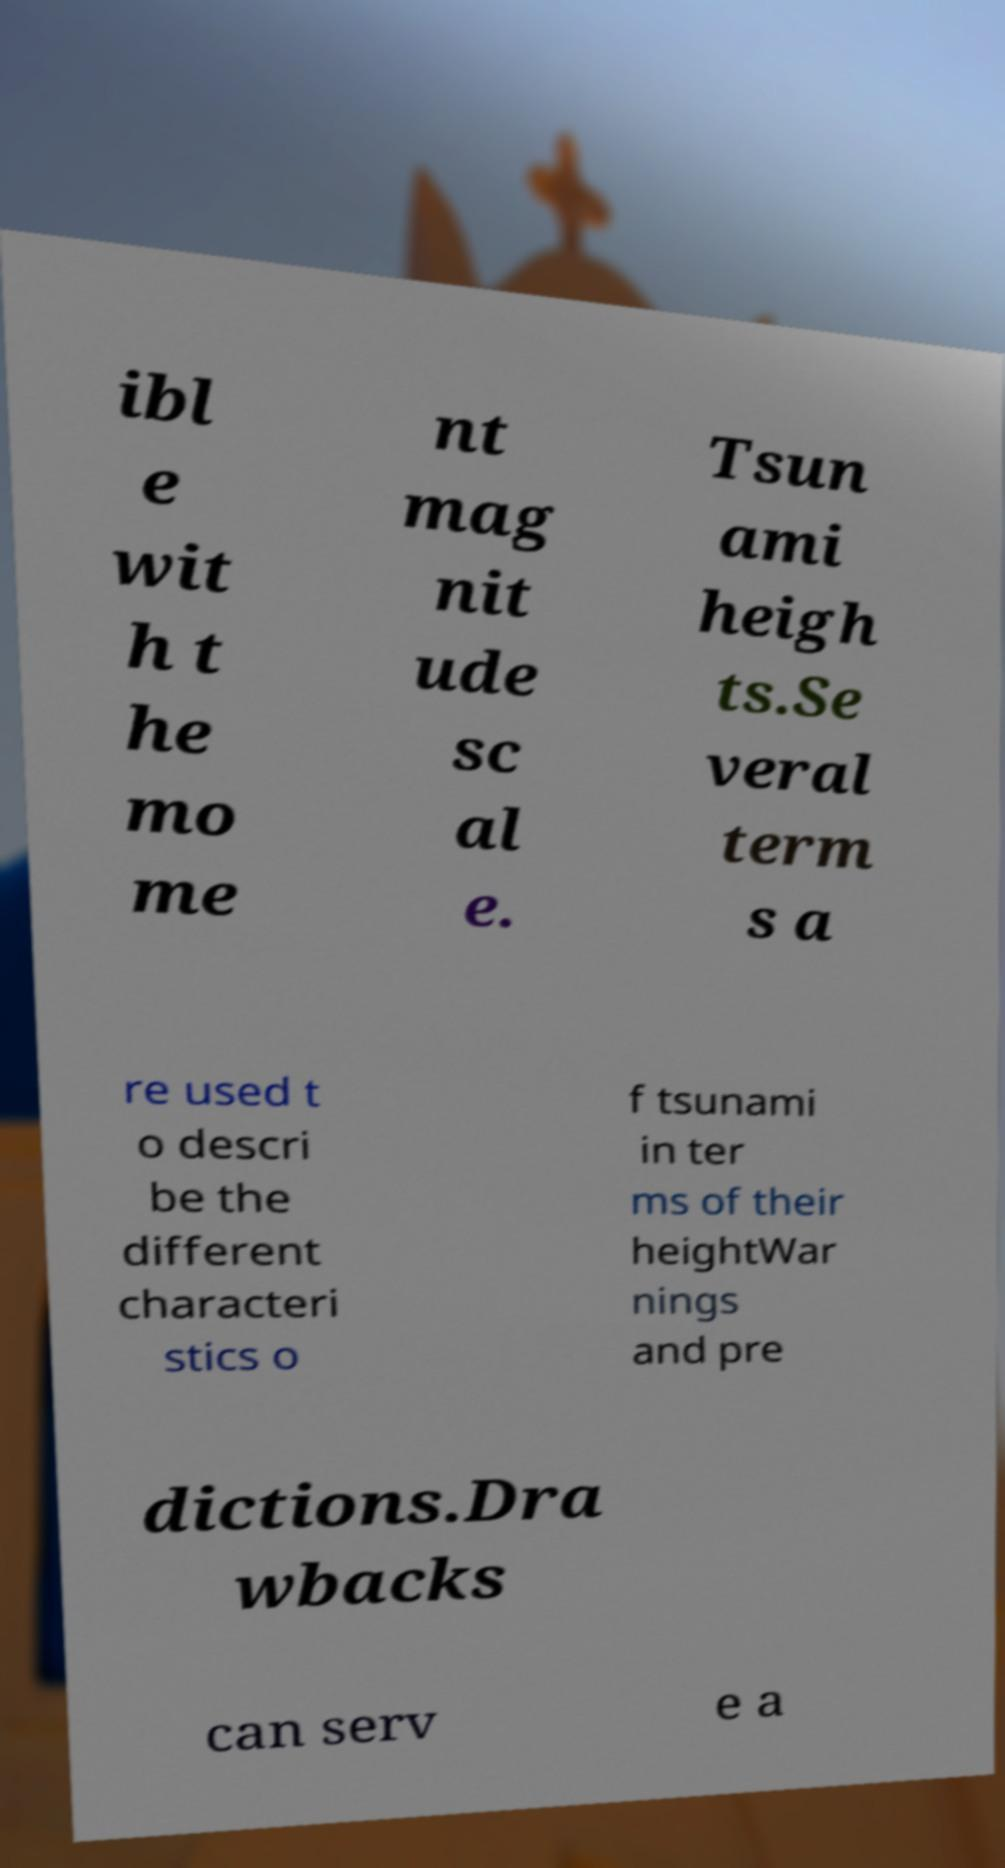Please identify and transcribe the text found in this image. ibl e wit h t he mo me nt mag nit ude sc al e. Tsun ami heigh ts.Se veral term s a re used t o descri be the different characteri stics o f tsunami in ter ms of their heightWar nings and pre dictions.Dra wbacks can serv e a 